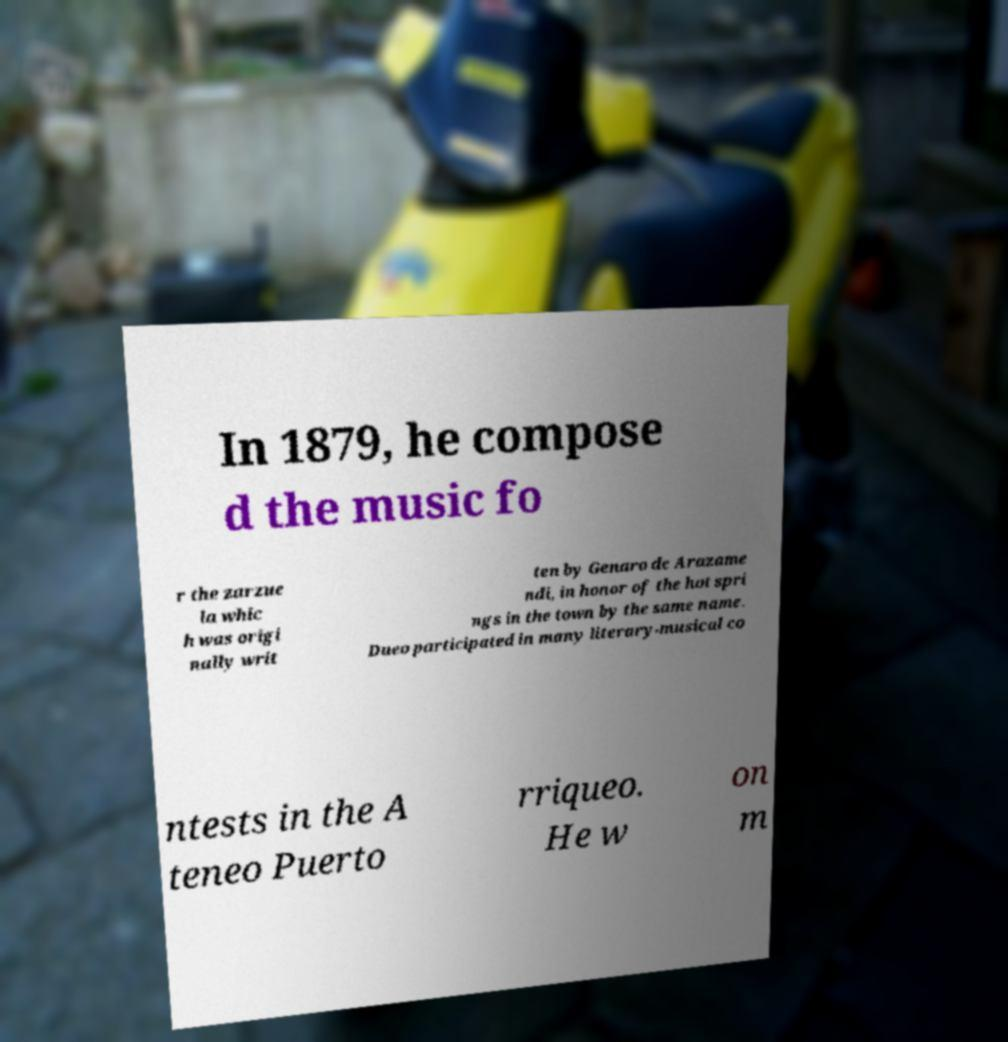Could you assist in decoding the text presented in this image and type it out clearly? In 1879, he compose d the music fo r the zarzue la whic h was origi nally writ ten by Genaro de Arazame ndi, in honor of the hot spri ngs in the town by the same name. Dueo participated in many literary-musical co ntests in the A teneo Puerto rriqueo. He w on m 